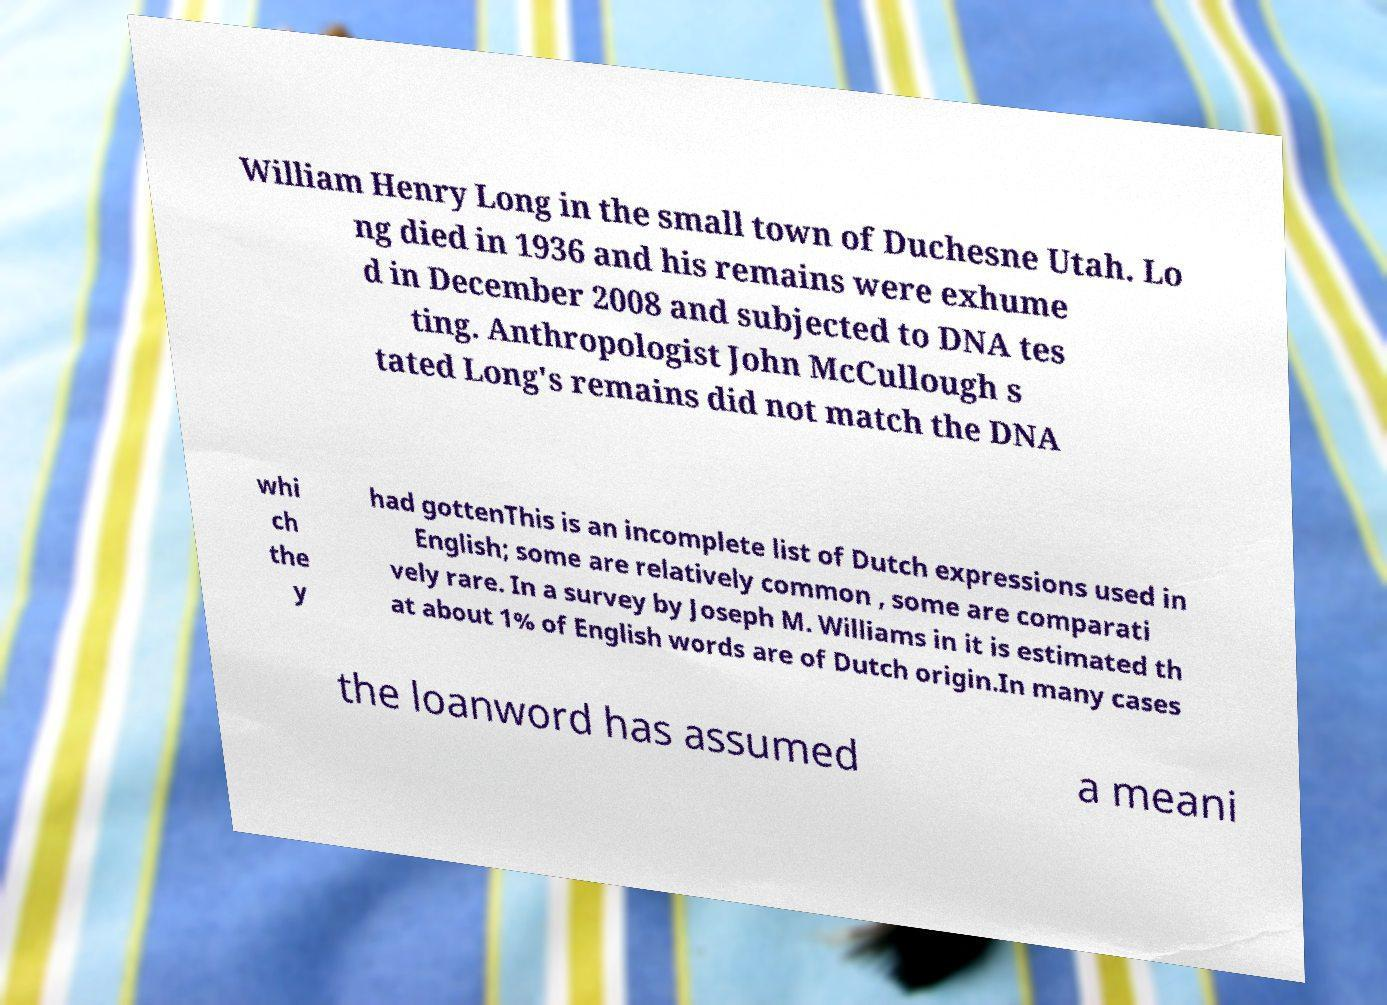What messages or text are displayed in this image? I need them in a readable, typed format. William Henry Long in the small town of Duchesne Utah. Lo ng died in 1936 and his remains were exhume d in December 2008 and subjected to DNA tes ting. Anthropologist John McCullough s tated Long's remains did not match the DNA whi ch the y had gottenThis is an incomplete list of Dutch expressions used in English; some are relatively common , some are comparati vely rare. In a survey by Joseph M. Williams in it is estimated th at about 1% of English words are of Dutch origin.In many cases the loanword has assumed a meani 